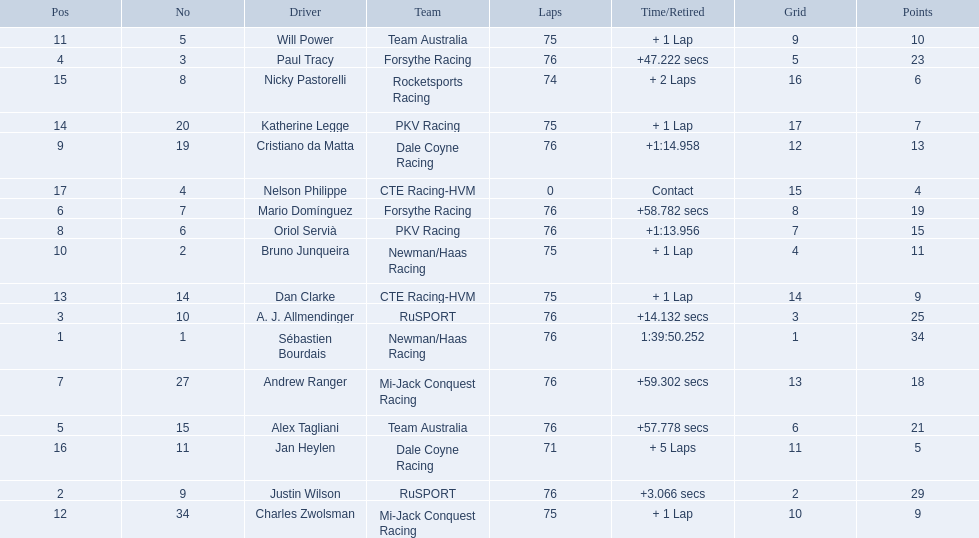Which drivers completed all 76 laps? Sébastien Bourdais, Justin Wilson, A. J. Allmendinger, Paul Tracy, Alex Tagliani, Mario Domínguez, Andrew Ranger, Oriol Servià, Cristiano da Matta. Of these drivers, which ones finished less than a minute behind first place? Paul Tracy, Alex Tagliani, Mario Domínguez, Andrew Ranger. Of these drivers, which ones finished with a time less than 50 seconds behind first place? Justin Wilson, A. J. Allmendinger, Paul Tracy. Of these three drivers, who finished last? Paul Tracy. 